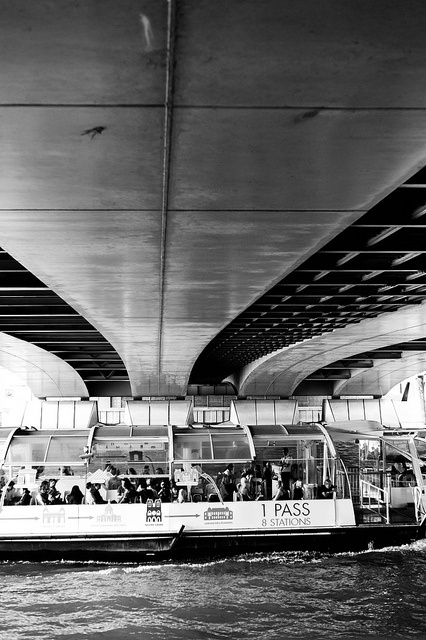Describe the objects in this image and their specific colors. I can see boat in black, white, darkgray, and gray tones, people in black, white, gray, and darkgray tones, people in black, gray, darkgray, and lightgray tones, people in black, gray, darkgray, and white tones, and people in black, gray, lightgray, and darkgray tones in this image. 